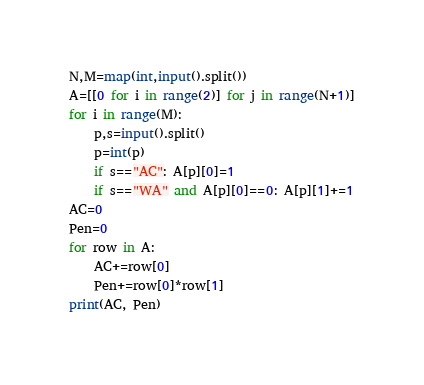Convert code to text. <code><loc_0><loc_0><loc_500><loc_500><_Python_>N,M=map(int,input().split())
A=[[0 for i in range(2)] for j in range(N+1)]
for i in range(M):
    p,s=input().split()
    p=int(p)
    if s=="AC": A[p][0]=1
    if s=="WA" and A[p][0]==0: A[p][1]+=1
AC=0
Pen=0
for row in A:
    AC+=row[0]
    Pen+=row[0]*row[1]
print(AC, Pen)</code> 